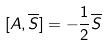<formula> <loc_0><loc_0><loc_500><loc_500>[ A , \overline { S } ] = - \frac { 1 } { 2 } \overline { S }</formula> 